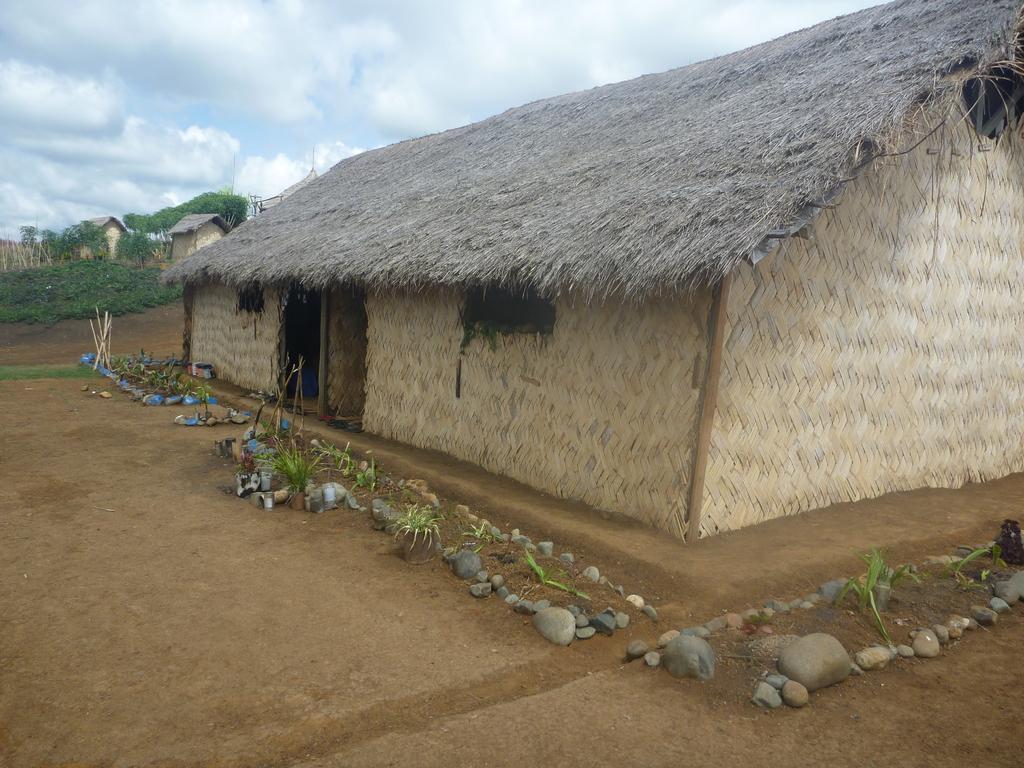In one or two sentences, can you explain what this image depicts? In this image we can see three huts, one object behind the hut looks like a hut roof, two objects looks like poles, some objects on the ground, some sticks, some stones, some trees, some plants and grass on the ground. At the top there is the cloudy sky. 